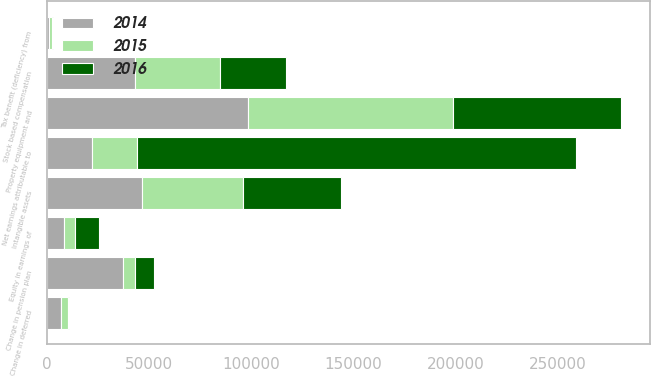Convert chart to OTSL. <chart><loc_0><loc_0><loc_500><loc_500><stacked_bar_chart><ecel><fcel>Net earnings attributable to<fcel>Property equipment and<fcel>Intangible assets<fcel>Stock based compensation<fcel>Tax benefit (deficiency) from<fcel>Equity in earnings of<fcel>Change in pension plan<fcel>Change in deferred<nl><fcel>2016<fcel>214515<fcel>82363<fcel>47608<fcel>32370<fcel>377<fcel>11892<fcel>9380<fcel>576<nl><fcel>2015<fcel>22131<fcel>99924<fcel>49368<fcel>41412<fcel>1237<fcel>5483<fcel>5980<fcel>3229<nl><fcel>2014<fcel>22131<fcel>98592<fcel>46820<fcel>43400<fcel>1344<fcel>8394<fcel>37218<fcel>7062<nl></chart> 